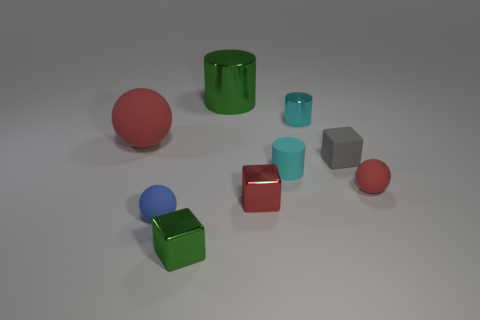Subtract all big green shiny cylinders. How many cylinders are left? 2 Subtract all green cylinders. How many cylinders are left? 2 Subtract all spheres. How many objects are left? 6 Add 1 yellow metallic spheres. How many objects exist? 10 Subtract all brown cylinders. How many red balls are left? 2 Subtract all tiny matte spheres. Subtract all small blocks. How many objects are left? 4 Add 8 small spheres. How many small spheres are left? 10 Add 4 tiny rubber cubes. How many tiny rubber cubes exist? 5 Subtract 1 gray cubes. How many objects are left? 8 Subtract 1 cylinders. How many cylinders are left? 2 